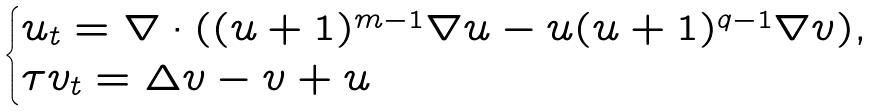Convert formula to latex. <formula><loc_0><loc_0><loc_500><loc_500>\begin{cases} u _ { t } = \nabla \cdot ( ( u + 1 ) ^ { m - 1 } \nabla u - u ( u + 1 ) ^ { q - 1 } \nabla v ) , \\ \tau v _ { t } = \Delta v - v + u \end{cases}</formula> 